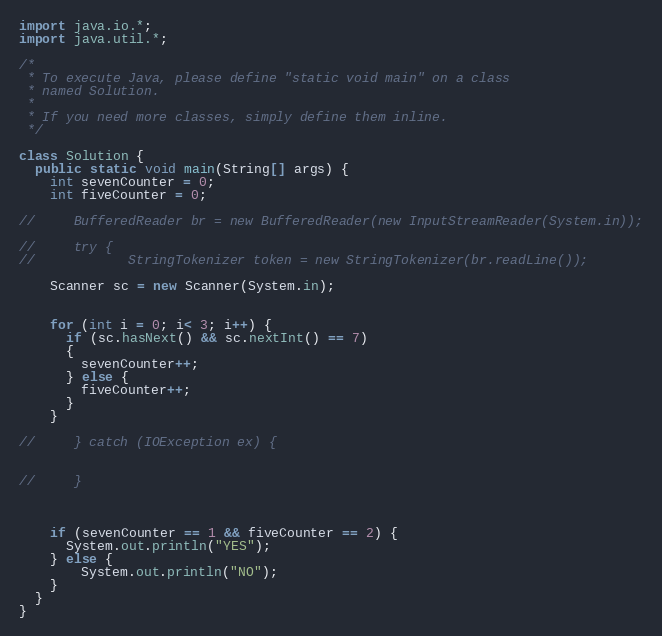<code> <loc_0><loc_0><loc_500><loc_500><_Java_>import java.io.*;
import java.util.*;

/*
 * To execute Java, please define "static void main" on a class
 * named Solution.
 *
 * If you need more classes, simply define them inline.
 */

class Solution {
  public static void main(String[] args) {
    int sevenCounter = 0;
    int fiveCounter = 0;
    
//     BufferedReader br = new BufferedReader(new InputStreamReader(System.in));
    
//     try {
//            StringTokenizer token = new StringTokenizer(br.readLine());
    
    Scanner sc = new Scanner(System.in);
    
    
    for (int i = 0; i< 3; i++) {
      if (sc.hasNext() && sc.nextInt() == 7)
      {
        sevenCounter++;
      } else {
        fiveCounter++; 
      }
    }
      
//     } catch (IOException ex) {
      
      
//     }
    
   
    
    if (sevenCounter == 1 && fiveCounter == 2) {
      System.out.println("YES"); 
    } else {
        System.out.println("NO"); 
    }
  }
}
</code> 